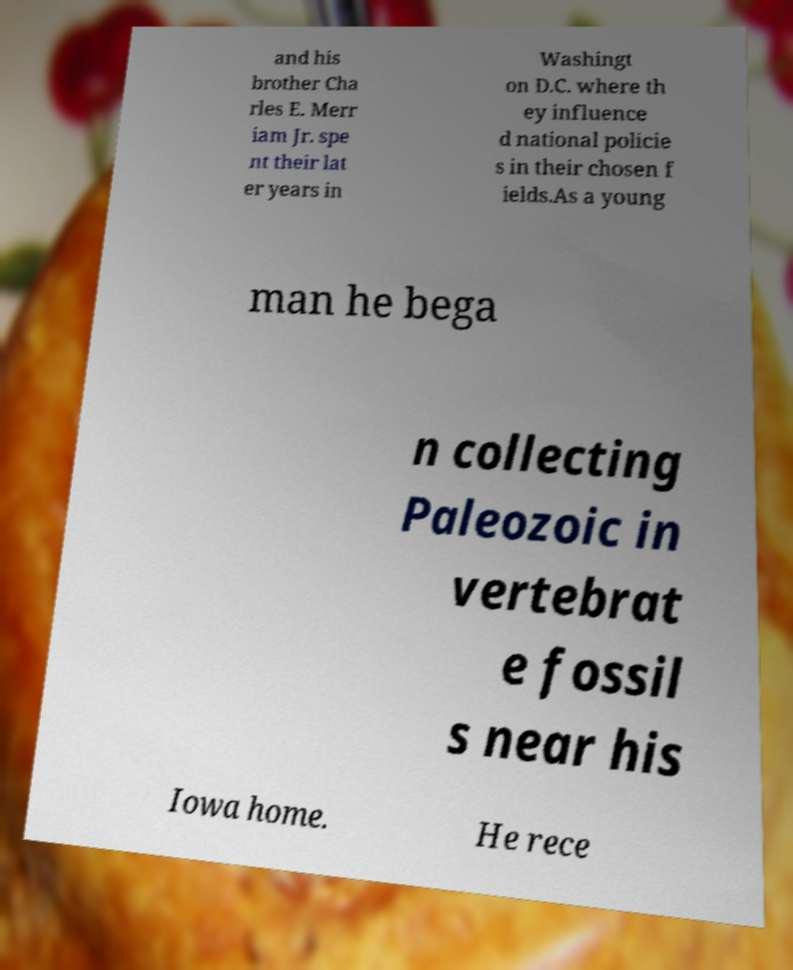Could you assist in decoding the text presented in this image and type it out clearly? and his brother Cha rles E. Merr iam Jr. spe nt their lat er years in Washingt on D.C. where th ey influence d national policie s in their chosen f ields.As a young man he bega n collecting Paleozoic in vertebrat e fossil s near his Iowa home. He rece 